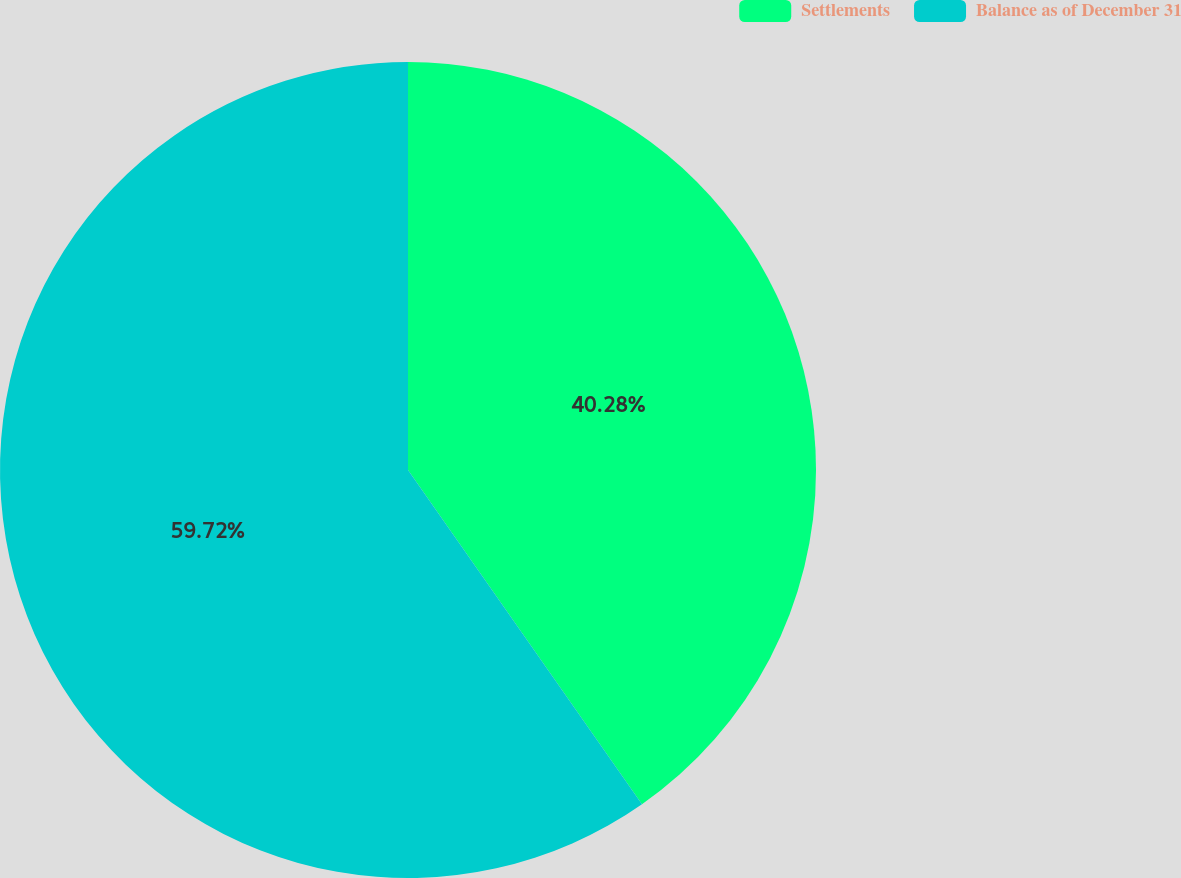Convert chart. <chart><loc_0><loc_0><loc_500><loc_500><pie_chart><fcel>Settlements<fcel>Balance as of December 31<nl><fcel>40.28%<fcel>59.72%<nl></chart> 